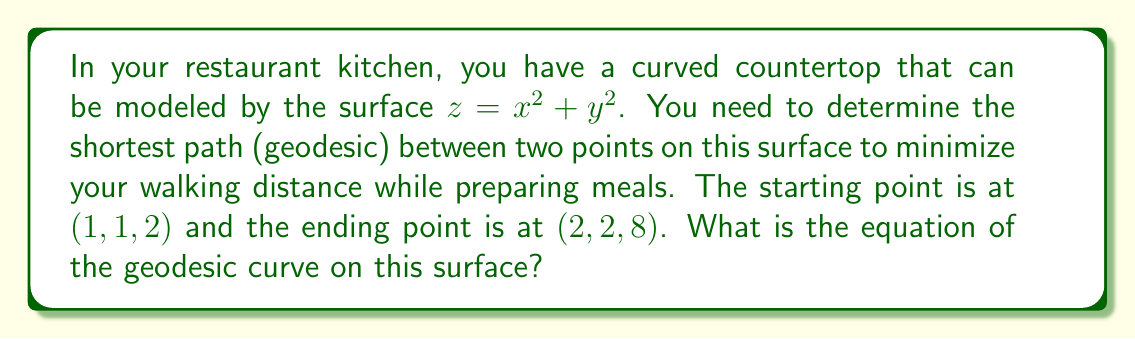What is the answer to this math problem? To find the geodesic on the given surface, we'll follow these steps:

1. Identify the surface equation:
   $z = x^2 + y^2$

2. Calculate the metric tensor components:
   $g_{11} = 1 + (\frac{\partial z}{\partial x})^2 = 1 + (2x)^2 = 1 + 4x^2$
   $g_{12} = g_{21} = \frac{\partial z}{\partial x} \frac{\partial z}{\partial y} = (2x)(2y) = 4xy$
   $g_{22} = 1 + (\frac{\partial z}{\partial y})^2 = 1 + (2y)^2 = 1 + 4y^2$

3. Set up the geodesic equations:
   $$\frac{d^2x}{ds^2} + \Gamma^1_{11}(\frac{dx}{ds})^2 + 2\Gamma^1_{12}\frac{dx}{ds}\frac{dy}{ds} + \Gamma^1_{22}(\frac{dy}{ds})^2 = 0$$
   $$\frac{d^2y}{ds^2} + \Gamma^2_{11}(\frac{dx}{ds})^2 + 2\Gamma^2_{12}\frac{dx}{ds}\frac{dy}{ds} + \Gamma^2_{22}(\frac{dy}{ds})^2 = 0$$

   Where $\Gamma^i_{jk}$ are the Christoffel symbols.

4. Calculate the Christoffel symbols:
   $\Gamma^1_{11} = \frac{2x}{1+4x^2}$, $\Gamma^1_{12} = \Gamma^1_{21} = \frac{-2y}{1+4x^2}$, $\Gamma^1_{22} = \frac{2x}{1+4x^2}$
   $\Gamma^2_{11} = \frac{-2x}{1+4y^2}$, $\Gamma^2_{12} = \Gamma^2_{21} = \frac{2y}{1+4y^2}$, $\Gamma^2_{22} = \frac{2y}{1+4y^2}$

5. Substitute these into the geodesic equations:
   $$\frac{d^2x}{ds^2} + \frac{2x}{1+4x^2}(\frac{dx}{ds})^2 - \frac{4y}{1+4x^2}\frac{dx}{ds}\frac{dy}{ds} + \frac{2x}{1+4x^2}(\frac{dy}{ds})^2 = 0$$
   $$\frac{d^2y}{ds^2} - \frac{2x}{1+4y^2}(\frac{dx}{ds})^2 + \frac{4y}{1+4y^2}\frac{dx}{ds}\frac{dy}{ds} + \frac{2y}{1+4y^2}(\frac{dy}{ds})^2 = 0$$

6. These differential equations are complex and generally require numerical methods to solve. However, due to the symmetry of the surface and the given points, we can deduce that the geodesic will be a straight line in the xy-plane.

7. The equation of a straight line passing through $(1,1)$ and $(2,2)$ is:
   $y = x$

8. Substituting this into the surface equation:
   $z = x^2 + y^2 = x^2 + x^2 = 2x^2$

Therefore, the equation of the geodesic curve on this surface is:
$$z = 2x^2, y = x$$
Answer: $z = 2x^2, y = x$ 